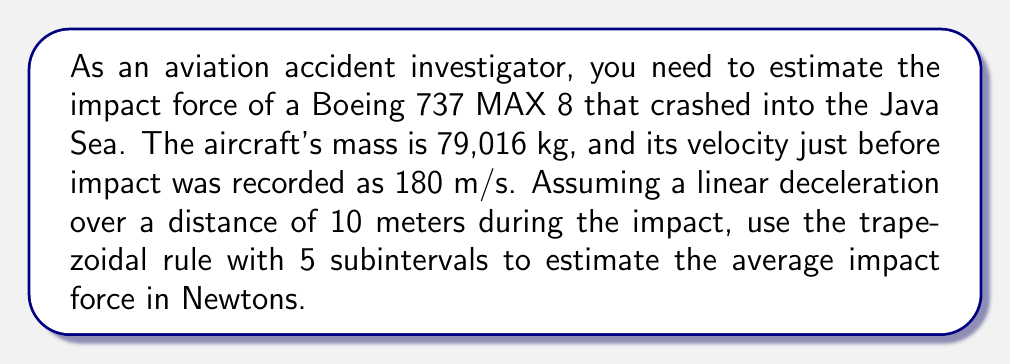Provide a solution to this math problem. To solve this problem, we'll follow these steps:

1) First, recall Newton's Second Law: $F = ma$, where $F$ is force, $m$ is mass, and $a$ is acceleration.

2) We need to find the average acceleration during the impact. We can use the equation:
   $v^2 = u^2 + 2as$
   Where $v$ is final velocity (0 m/s), $u$ is initial velocity (180 m/s), $a$ is acceleration, and $s$ is distance (10 m).

3) Rearranging and solving for $a$:
   $a = \frac{v^2 - u^2}{2s} = \frac{0^2 - 180^2}{2(10)} = -1620$ m/s²

4) Now, we can set up the integral for the average force:
   $F_{avg} = \frac{1}{10} \int_0^{10} m \cdot a(x) dx$

   Where $a(x)$ is the acceleration as a function of distance $x$. Since we're assuming linear deceleration, $a(x)$ is:
   $a(x) = -1620 \cdot (1 - \frac{x}{10})$

5) Our integral becomes:
   $F_{avg} = \frac{79016}{10} \int_0^{10} -1620 \cdot (1 - \frac{x}{10}) dx$

6) To apply the trapezoidal rule with 5 subintervals, we'll use the formula:
   $\int_a^b f(x) dx \approx \frac{h}{2}[f(x_0) + 2f(x_1) + 2f(x_2) + 2f(x_3) + 2f(x_4) + f(x_5)]$

   Where $h = \frac{b-a}{n} = \frac{10-0}{5} = 2$

7) Calculate $f(x)$ at each point:
   $f(0) = -1620$
   $f(2) = -1296$
   $f(4) = -972$
   $f(6) = -648$
   $f(8) = -324$
   $f(10) = 0$

8) Apply the trapezoidal rule:
   $\int_0^{10} -1620 \cdot (1 - \frac{x}{10}) dx \approx \frac{2}{2}[-1620 + 2(-1296) + 2(-972) + 2(-648) + 2(-324) + 0]$
   $= -8100$

9) Finally, calculate the average force:
   $F_{avg} = \frac{79016}{10} \cdot (-8100) = -64002960$ N

The negative sign indicates the force is in the opposite direction of the motion.
Answer: 64,002,960 N 